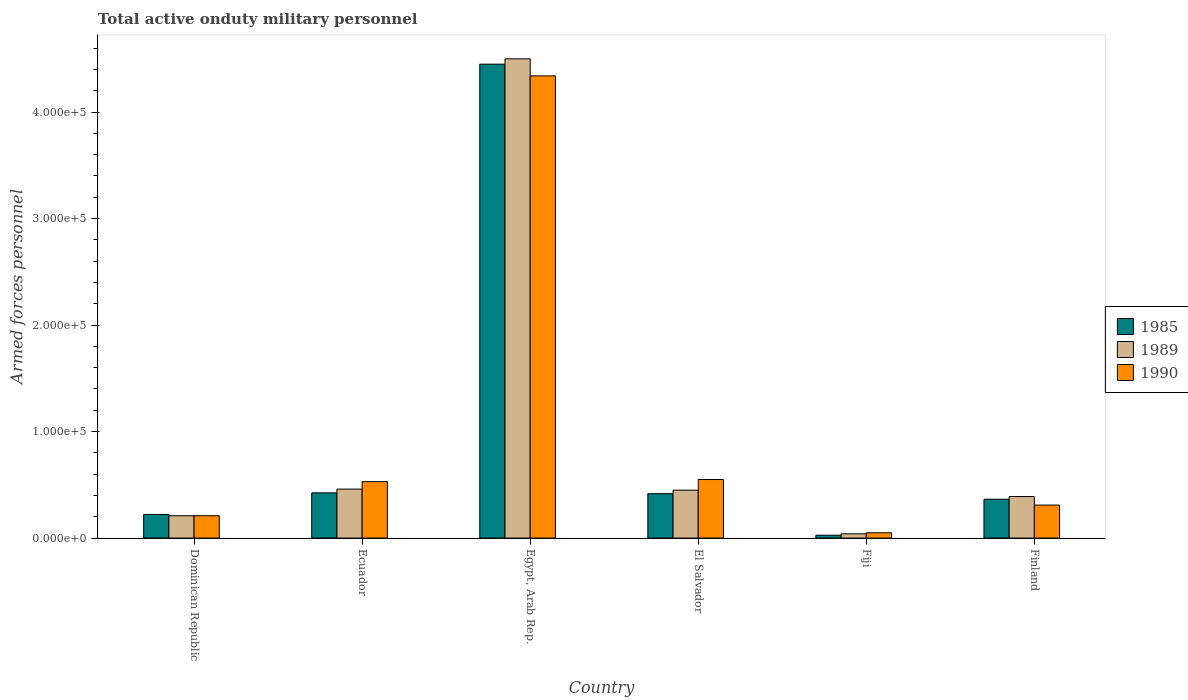How many different coloured bars are there?
Give a very brief answer. 3. How many groups of bars are there?
Ensure brevity in your answer.  6. What is the number of armed forces personnel in 1985 in Egypt, Arab Rep.?
Offer a very short reply. 4.45e+05. Across all countries, what is the minimum number of armed forces personnel in 1985?
Keep it short and to the point. 2700. In which country was the number of armed forces personnel in 1990 maximum?
Ensure brevity in your answer.  Egypt, Arab Rep. In which country was the number of armed forces personnel in 1985 minimum?
Give a very brief answer. Fiji. What is the total number of armed forces personnel in 1990 in the graph?
Give a very brief answer. 5.99e+05. What is the difference between the number of armed forces personnel in 1990 in Dominican Republic and that in Ecuador?
Make the answer very short. -3.20e+04. What is the difference between the number of armed forces personnel in 1985 in El Salvador and the number of armed forces personnel in 1990 in Ecuador?
Keep it short and to the point. -1.13e+04. What is the average number of armed forces personnel in 1989 per country?
Give a very brief answer. 1.01e+05. What is the difference between the number of armed forces personnel of/in 1989 and number of armed forces personnel of/in 1985 in Egypt, Arab Rep.?
Make the answer very short. 5000. In how many countries, is the number of armed forces personnel in 1989 greater than 420000?
Offer a very short reply. 1. What is the ratio of the number of armed forces personnel in 1985 in Ecuador to that in Finland?
Provide a short and direct response. 1.16. Is the difference between the number of armed forces personnel in 1989 in El Salvador and Fiji greater than the difference between the number of armed forces personnel in 1985 in El Salvador and Fiji?
Offer a very short reply. Yes. What is the difference between the highest and the second highest number of armed forces personnel in 1990?
Provide a succinct answer. 3.81e+05. What is the difference between the highest and the lowest number of armed forces personnel in 1985?
Make the answer very short. 4.42e+05. Does the graph contain grids?
Give a very brief answer. No. Where does the legend appear in the graph?
Give a very brief answer. Center right. What is the title of the graph?
Provide a short and direct response. Total active onduty military personnel. Does "1985" appear as one of the legend labels in the graph?
Offer a very short reply. Yes. What is the label or title of the X-axis?
Give a very brief answer. Country. What is the label or title of the Y-axis?
Keep it short and to the point. Armed forces personnel. What is the Armed forces personnel of 1985 in Dominican Republic?
Make the answer very short. 2.22e+04. What is the Armed forces personnel in 1989 in Dominican Republic?
Provide a short and direct response. 2.10e+04. What is the Armed forces personnel in 1990 in Dominican Republic?
Your response must be concise. 2.10e+04. What is the Armed forces personnel of 1985 in Ecuador?
Provide a succinct answer. 4.25e+04. What is the Armed forces personnel in 1989 in Ecuador?
Provide a short and direct response. 4.60e+04. What is the Armed forces personnel of 1990 in Ecuador?
Provide a short and direct response. 5.30e+04. What is the Armed forces personnel in 1985 in Egypt, Arab Rep.?
Provide a succinct answer. 4.45e+05. What is the Armed forces personnel in 1989 in Egypt, Arab Rep.?
Provide a succinct answer. 4.50e+05. What is the Armed forces personnel of 1990 in Egypt, Arab Rep.?
Your response must be concise. 4.34e+05. What is the Armed forces personnel of 1985 in El Salvador?
Offer a terse response. 4.17e+04. What is the Armed forces personnel of 1989 in El Salvador?
Your response must be concise. 4.50e+04. What is the Armed forces personnel in 1990 in El Salvador?
Offer a terse response. 5.50e+04. What is the Armed forces personnel in 1985 in Fiji?
Ensure brevity in your answer.  2700. What is the Armed forces personnel in 1989 in Fiji?
Make the answer very short. 4000. What is the Armed forces personnel of 1990 in Fiji?
Make the answer very short. 5000. What is the Armed forces personnel of 1985 in Finland?
Offer a very short reply. 3.65e+04. What is the Armed forces personnel of 1989 in Finland?
Offer a very short reply. 3.90e+04. What is the Armed forces personnel of 1990 in Finland?
Provide a short and direct response. 3.10e+04. Across all countries, what is the maximum Armed forces personnel of 1985?
Make the answer very short. 4.45e+05. Across all countries, what is the maximum Armed forces personnel of 1990?
Ensure brevity in your answer.  4.34e+05. Across all countries, what is the minimum Armed forces personnel in 1985?
Your answer should be compact. 2700. Across all countries, what is the minimum Armed forces personnel in 1989?
Give a very brief answer. 4000. What is the total Armed forces personnel in 1985 in the graph?
Ensure brevity in your answer.  5.91e+05. What is the total Armed forces personnel in 1989 in the graph?
Give a very brief answer. 6.05e+05. What is the total Armed forces personnel of 1990 in the graph?
Your answer should be compact. 5.99e+05. What is the difference between the Armed forces personnel of 1985 in Dominican Republic and that in Ecuador?
Your response must be concise. -2.03e+04. What is the difference between the Armed forces personnel in 1989 in Dominican Republic and that in Ecuador?
Keep it short and to the point. -2.50e+04. What is the difference between the Armed forces personnel in 1990 in Dominican Republic and that in Ecuador?
Keep it short and to the point. -3.20e+04. What is the difference between the Armed forces personnel in 1985 in Dominican Republic and that in Egypt, Arab Rep.?
Provide a short and direct response. -4.23e+05. What is the difference between the Armed forces personnel of 1989 in Dominican Republic and that in Egypt, Arab Rep.?
Keep it short and to the point. -4.29e+05. What is the difference between the Armed forces personnel in 1990 in Dominican Republic and that in Egypt, Arab Rep.?
Ensure brevity in your answer.  -4.13e+05. What is the difference between the Armed forces personnel of 1985 in Dominican Republic and that in El Salvador?
Provide a succinct answer. -1.95e+04. What is the difference between the Armed forces personnel of 1989 in Dominican Republic and that in El Salvador?
Offer a terse response. -2.40e+04. What is the difference between the Armed forces personnel in 1990 in Dominican Republic and that in El Salvador?
Offer a terse response. -3.40e+04. What is the difference between the Armed forces personnel in 1985 in Dominican Republic and that in Fiji?
Ensure brevity in your answer.  1.95e+04. What is the difference between the Armed forces personnel of 1989 in Dominican Republic and that in Fiji?
Your answer should be compact. 1.70e+04. What is the difference between the Armed forces personnel in 1990 in Dominican Republic and that in Fiji?
Offer a very short reply. 1.60e+04. What is the difference between the Armed forces personnel of 1985 in Dominican Republic and that in Finland?
Offer a terse response. -1.43e+04. What is the difference between the Armed forces personnel of 1989 in Dominican Republic and that in Finland?
Give a very brief answer. -1.80e+04. What is the difference between the Armed forces personnel of 1985 in Ecuador and that in Egypt, Arab Rep.?
Provide a short and direct response. -4.02e+05. What is the difference between the Armed forces personnel of 1989 in Ecuador and that in Egypt, Arab Rep.?
Provide a succinct answer. -4.04e+05. What is the difference between the Armed forces personnel in 1990 in Ecuador and that in Egypt, Arab Rep.?
Make the answer very short. -3.81e+05. What is the difference between the Armed forces personnel of 1985 in Ecuador and that in El Salvador?
Offer a very short reply. 800. What is the difference between the Armed forces personnel in 1989 in Ecuador and that in El Salvador?
Make the answer very short. 1000. What is the difference between the Armed forces personnel of 1990 in Ecuador and that in El Salvador?
Give a very brief answer. -2000. What is the difference between the Armed forces personnel of 1985 in Ecuador and that in Fiji?
Provide a short and direct response. 3.98e+04. What is the difference between the Armed forces personnel in 1989 in Ecuador and that in Fiji?
Your response must be concise. 4.20e+04. What is the difference between the Armed forces personnel in 1990 in Ecuador and that in Fiji?
Your response must be concise. 4.80e+04. What is the difference between the Armed forces personnel in 1985 in Ecuador and that in Finland?
Offer a very short reply. 6000. What is the difference between the Armed forces personnel in 1989 in Ecuador and that in Finland?
Your response must be concise. 7000. What is the difference between the Armed forces personnel in 1990 in Ecuador and that in Finland?
Offer a very short reply. 2.20e+04. What is the difference between the Armed forces personnel of 1985 in Egypt, Arab Rep. and that in El Salvador?
Your answer should be very brief. 4.03e+05. What is the difference between the Armed forces personnel in 1989 in Egypt, Arab Rep. and that in El Salvador?
Your answer should be compact. 4.05e+05. What is the difference between the Armed forces personnel of 1990 in Egypt, Arab Rep. and that in El Salvador?
Keep it short and to the point. 3.79e+05. What is the difference between the Armed forces personnel of 1985 in Egypt, Arab Rep. and that in Fiji?
Provide a short and direct response. 4.42e+05. What is the difference between the Armed forces personnel of 1989 in Egypt, Arab Rep. and that in Fiji?
Make the answer very short. 4.46e+05. What is the difference between the Armed forces personnel of 1990 in Egypt, Arab Rep. and that in Fiji?
Offer a very short reply. 4.29e+05. What is the difference between the Armed forces personnel of 1985 in Egypt, Arab Rep. and that in Finland?
Your response must be concise. 4.08e+05. What is the difference between the Armed forces personnel of 1989 in Egypt, Arab Rep. and that in Finland?
Offer a terse response. 4.11e+05. What is the difference between the Armed forces personnel in 1990 in Egypt, Arab Rep. and that in Finland?
Make the answer very short. 4.03e+05. What is the difference between the Armed forces personnel of 1985 in El Salvador and that in Fiji?
Your answer should be very brief. 3.90e+04. What is the difference between the Armed forces personnel in 1989 in El Salvador and that in Fiji?
Offer a very short reply. 4.10e+04. What is the difference between the Armed forces personnel in 1990 in El Salvador and that in Fiji?
Offer a very short reply. 5.00e+04. What is the difference between the Armed forces personnel in 1985 in El Salvador and that in Finland?
Make the answer very short. 5200. What is the difference between the Armed forces personnel of 1989 in El Salvador and that in Finland?
Offer a terse response. 6000. What is the difference between the Armed forces personnel in 1990 in El Salvador and that in Finland?
Offer a terse response. 2.40e+04. What is the difference between the Armed forces personnel in 1985 in Fiji and that in Finland?
Provide a succinct answer. -3.38e+04. What is the difference between the Armed forces personnel in 1989 in Fiji and that in Finland?
Offer a terse response. -3.50e+04. What is the difference between the Armed forces personnel of 1990 in Fiji and that in Finland?
Offer a terse response. -2.60e+04. What is the difference between the Armed forces personnel of 1985 in Dominican Republic and the Armed forces personnel of 1989 in Ecuador?
Give a very brief answer. -2.38e+04. What is the difference between the Armed forces personnel in 1985 in Dominican Republic and the Armed forces personnel in 1990 in Ecuador?
Offer a very short reply. -3.08e+04. What is the difference between the Armed forces personnel of 1989 in Dominican Republic and the Armed forces personnel of 1990 in Ecuador?
Your answer should be very brief. -3.20e+04. What is the difference between the Armed forces personnel of 1985 in Dominican Republic and the Armed forces personnel of 1989 in Egypt, Arab Rep.?
Your answer should be compact. -4.28e+05. What is the difference between the Armed forces personnel in 1985 in Dominican Republic and the Armed forces personnel in 1990 in Egypt, Arab Rep.?
Keep it short and to the point. -4.12e+05. What is the difference between the Armed forces personnel in 1989 in Dominican Republic and the Armed forces personnel in 1990 in Egypt, Arab Rep.?
Your answer should be very brief. -4.13e+05. What is the difference between the Armed forces personnel of 1985 in Dominican Republic and the Armed forces personnel of 1989 in El Salvador?
Your response must be concise. -2.28e+04. What is the difference between the Armed forces personnel of 1985 in Dominican Republic and the Armed forces personnel of 1990 in El Salvador?
Your answer should be very brief. -3.28e+04. What is the difference between the Armed forces personnel of 1989 in Dominican Republic and the Armed forces personnel of 1990 in El Salvador?
Ensure brevity in your answer.  -3.40e+04. What is the difference between the Armed forces personnel of 1985 in Dominican Republic and the Armed forces personnel of 1989 in Fiji?
Offer a very short reply. 1.82e+04. What is the difference between the Armed forces personnel of 1985 in Dominican Republic and the Armed forces personnel of 1990 in Fiji?
Provide a succinct answer. 1.72e+04. What is the difference between the Armed forces personnel in 1989 in Dominican Republic and the Armed forces personnel in 1990 in Fiji?
Your answer should be compact. 1.60e+04. What is the difference between the Armed forces personnel in 1985 in Dominican Republic and the Armed forces personnel in 1989 in Finland?
Provide a succinct answer. -1.68e+04. What is the difference between the Armed forces personnel in 1985 in Dominican Republic and the Armed forces personnel in 1990 in Finland?
Keep it short and to the point. -8800. What is the difference between the Armed forces personnel of 1985 in Ecuador and the Armed forces personnel of 1989 in Egypt, Arab Rep.?
Your response must be concise. -4.08e+05. What is the difference between the Armed forces personnel of 1985 in Ecuador and the Armed forces personnel of 1990 in Egypt, Arab Rep.?
Your answer should be very brief. -3.92e+05. What is the difference between the Armed forces personnel of 1989 in Ecuador and the Armed forces personnel of 1990 in Egypt, Arab Rep.?
Provide a short and direct response. -3.88e+05. What is the difference between the Armed forces personnel in 1985 in Ecuador and the Armed forces personnel in 1989 in El Salvador?
Your response must be concise. -2500. What is the difference between the Armed forces personnel of 1985 in Ecuador and the Armed forces personnel of 1990 in El Salvador?
Offer a very short reply. -1.25e+04. What is the difference between the Armed forces personnel in 1989 in Ecuador and the Armed forces personnel in 1990 in El Salvador?
Provide a short and direct response. -9000. What is the difference between the Armed forces personnel of 1985 in Ecuador and the Armed forces personnel of 1989 in Fiji?
Make the answer very short. 3.85e+04. What is the difference between the Armed forces personnel in 1985 in Ecuador and the Armed forces personnel in 1990 in Fiji?
Provide a succinct answer. 3.75e+04. What is the difference between the Armed forces personnel of 1989 in Ecuador and the Armed forces personnel of 1990 in Fiji?
Make the answer very short. 4.10e+04. What is the difference between the Armed forces personnel in 1985 in Ecuador and the Armed forces personnel in 1989 in Finland?
Offer a very short reply. 3500. What is the difference between the Armed forces personnel of 1985 in Ecuador and the Armed forces personnel of 1990 in Finland?
Your response must be concise. 1.15e+04. What is the difference between the Armed forces personnel in 1989 in Ecuador and the Armed forces personnel in 1990 in Finland?
Offer a terse response. 1.50e+04. What is the difference between the Armed forces personnel of 1985 in Egypt, Arab Rep. and the Armed forces personnel of 1989 in El Salvador?
Give a very brief answer. 4.00e+05. What is the difference between the Armed forces personnel of 1985 in Egypt, Arab Rep. and the Armed forces personnel of 1990 in El Salvador?
Offer a terse response. 3.90e+05. What is the difference between the Armed forces personnel in 1989 in Egypt, Arab Rep. and the Armed forces personnel in 1990 in El Salvador?
Your answer should be compact. 3.95e+05. What is the difference between the Armed forces personnel in 1985 in Egypt, Arab Rep. and the Armed forces personnel in 1989 in Fiji?
Ensure brevity in your answer.  4.41e+05. What is the difference between the Armed forces personnel in 1989 in Egypt, Arab Rep. and the Armed forces personnel in 1990 in Fiji?
Your answer should be compact. 4.45e+05. What is the difference between the Armed forces personnel of 1985 in Egypt, Arab Rep. and the Armed forces personnel of 1989 in Finland?
Provide a short and direct response. 4.06e+05. What is the difference between the Armed forces personnel of 1985 in Egypt, Arab Rep. and the Armed forces personnel of 1990 in Finland?
Provide a short and direct response. 4.14e+05. What is the difference between the Armed forces personnel of 1989 in Egypt, Arab Rep. and the Armed forces personnel of 1990 in Finland?
Provide a succinct answer. 4.19e+05. What is the difference between the Armed forces personnel in 1985 in El Salvador and the Armed forces personnel in 1989 in Fiji?
Your answer should be very brief. 3.77e+04. What is the difference between the Armed forces personnel in 1985 in El Salvador and the Armed forces personnel in 1990 in Fiji?
Give a very brief answer. 3.67e+04. What is the difference between the Armed forces personnel of 1985 in El Salvador and the Armed forces personnel of 1989 in Finland?
Give a very brief answer. 2700. What is the difference between the Armed forces personnel in 1985 in El Salvador and the Armed forces personnel in 1990 in Finland?
Give a very brief answer. 1.07e+04. What is the difference between the Armed forces personnel in 1989 in El Salvador and the Armed forces personnel in 1990 in Finland?
Ensure brevity in your answer.  1.40e+04. What is the difference between the Armed forces personnel in 1985 in Fiji and the Armed forces personnel in 1989 in Finland?
Keep it short and to the point. -3.63e+04. What is the difference between the Armed forces personnel of 1985 in Fiji and the Armed forces personnel of 1990 in Finland?
Offer a terse response. -2.83e+04. What is the difference between the Armed forces personnel in 1989 in Fiji and the Armed forces personnel in 1990 in Finland?
Offer a very short reply. -2.70e+04. What is the average Armed forces personnel in 1985 per country?
Make the answer very short. 9.84e+04. What is the average Armed forces personnel in 1989 per country?
Ensure brevity in your answer.  1.01e+05. What is the average Armed forces personnel in 1990 per country?
Offer a very short reply. 9.98e+04. What is the difference between the Armed forces personnel of 1985 and Armed forces personnel of 1989 in Dominican Republic?
Offer a terse response. 1200. What is the difference between the Armed forces personnel of 1985 and Armed forces personnel of 1990 in Dominican Republic?
Ensure brevity in your answer.  1200. What is the difference between the Armed forces personnel of 1989 and Armed forces personnel of 1990 in Dominican Republic?
Provide a short and direct response. 0. What is the difference between the Armed forces personnel of 1985 and Armed forces personnel of 1989 in Ecuador?
Your response must be concise. -3500. What is the difference between the Armed forces personnel of 1985 and Armed forces personnel of 1990 in Ecuador?
Make the answer very short. -1.05e+04. What is the difference between the Armed forces personnel in 1989 and Armed forces personnel in 1990 in Ecuador?
Your answer should be very brief. -7000. What is the difference between the Armed forces personnel in 1985 and Armed forces personnel in 1989 in Egypt, Arab Rep.?
Provide a succinct answer. -5000. What is the difference between the Armed forces personnel of 1985 and Armed forces personnel of 1990 in Egypt, Arab Rep.?
Keep it short and to the point. 1.10e+04. What is the difference between the Armed forces personnel of 1989 and Armed forces personnel of 1990 in Egypt, Arab Rep.?
Make the answer very short. 1.60e+04. What is the difference between the Armed forces personnel in 1985 and Armed forces personnel in 1989 in El Salvador?
Keep it short and to the point. -3300. What is the difference between the Armed forces personnel of 1985 and Armed forces personnel of 1990 in El Salvador?
Provide a succinct answer. -1.33e+04. What is the difference between the Armed forces personnel in 1985 and Armed forces personnel in 1989 in Fiji?
Your answer should be compact. -1300. What is the difference between the Armed forces personnel in 1985 and Armed forces personnel in 1990 in Fiji?
Your answer should be very brief. -2300. What is the difference between the Armed forces personnel of 1989 and Armed forces personnel of 1990 in Fiji?
Give a very brief answer. -1000. What is the difference between the Armed forces personnel in 1985 and Armed forces personnel in 1989 in Finland?
Your answer should be compact. -2500. What is the difference between the Armed forces personnel in 1985 and Armed forces personnel in 1990 in Finland?
Keep it short and to the point. 5500. What is the difference between the Armed forces personnel of 1989 and Armed forces personnel of 1990 in Finland?
Give a very brief answer. 8000. What is the ratio of the Armed forces personnel in 1985 in Dominican Republic to that in Ecuador?
Make the answer very short. 0.52. What is the ratio of the Armed forces personnel in 1989 in Dominican Republic to that in Ecuador?
Ensure brevity in your answer.  0.46. What is the ratio of the Armed forces personnel in 1990 in Dominican Republic to that in Ecuador?
Your answer should be compact. 0.4. What is the ratio of the Armed forces personnel in 1985 in Dominican Republic to that in Egypt, Arab Rep.?
Make the answer very short. 0.05. What is the ratio of the Armed forces personnel in 1989 in Dominican Republic to that in Egypt, Arab Rep.?
Keep it short and to the point. 0.05. What is the ratio of the Armed forces personnel of 1990 in Dominican Republic to that in Egypt, Arab Rep.?
Offer a terse response. 0.05. What is the ratio of the Armed forces personnel in 1985 in Dominican Republic to that in El Salvador?
Keep it short and to the point. 0.53. What is the ratio of the Armed forces personnel of 1989 in Dominican Republic to that in El Salvador?
Provide a succinct answer. 0.47. What is the ratio of the Armed forces personnel of 1990 in Dominican Republic to that in El Salvador?
Offer a very short reply. 0.38. What is the ratio of the Armed forces personnel in 1985 in Dominican Republic to that in Fiji?
Ensure brevity in your answer.  8.22. What is the ratio of the Armed forces personnel of 1989 in Dominican Republic to that in Fiji?
Offer a very short reply. 5.25. What is the ratio of the Armed forces personnel of 1985 in Dominican Republic to that in Finland?
Provide a succinct answer. 0.61. What is the ratio of the Armed forces personnel of 1989 in Dominican Republic to that in Finland?
Provide a succinct answer. 0.54. What is the ratio of the Armed forces personnel in 1990 in Dominican Republic to that in Finland?
Offer a very short reply. 0.68. What is the ratio of the Armed forces personnel in 1985 in Ecuador to that in Egypt, Arab Rep.?
Keep it short and to the point. 0.1. What is the ratio of the Armed forces personnel of 1989 in Ecuador to that in Egypt, Arab Rep.?
Provide a succinct answer. 0.1. What is the ratio of the Armed forces personnel of 1990 in Ecuador to that in Egypt, Arab Rep.?
Ensure brevity in your answer.  0.12. What is the ratio of the Armed forces personnel in 1985 in Ecuador to that in El Salvador?
Provide a succinct answer. 1.02. What is the ratio of the Armed forces personnel in 1989 in Ecuador to that in El Salvador?
Keep it short and to the point. 1.02. What is the ratio of the Armed forces personnel in 1990 in Ecuador to that in El Salvador?
Ensure brevity in your answer.  0.96. What is the ratio of the Armed forces personnel of 1985 in Ecuador to that in Fiji?
Offer a terse response. 15.74. What is the ratio of the Armed forces personnel in 1989 in Ecuador to that in Fiji?
Provide a short and direct response. 11.5. What is the ratio of the Armed forces personnel in 1990 in Ecuador to that in Fiji?
Your answer should be compact. 10.6. What is the ratio of the Armed forces personnel in 1985 in Ecuador to that in Finland?
Keep it short and to the point. 1.16. What is the ratio of the Armed forces personnel of 1989 in Ecuador to that in Finland?
Provide a succinct answer. 1.18. What is the ratio of the Armed forces personnel in 1990 in Ecuador to that in Finland?
Offer a terse response. 1.71. What is the ratio of the Armed forces personnel of 1985 in Egypt, Arab Rep. to that in El Salvador?
Your response must be concise. 10.67. What is the ratio of the Armed forces personnel of 1990 in Egypt, Arab Rep. to that in El Salvador?
Provide a succinct answer. 7.89. What is the ratio of the Armed forces personnel of 1985 in Egypt, Arab Rep. to that in Fiji?
Ensure brevity in your answer.  164.81. What is the ratio of the Armed forces personnel in 1989 in Egypt, Arab Rep. to that in Fiji?
Provide a short and direct response. 112.5. What is the ratio of the Armed forces personnel in 1990 in Egypt, Arab Rep. to that in Fiji?
Give a very brief answer. 86.8. What is the ratio of the Armed forces personnel in 1985 in Egypt, Arab Rep. to that in Finland?
Offer a very short reply. 12.19. What is the ratio of the Armed forces personnel of 1989 in Egypt, Arab Rep. to that in Finland?
Give a very brief answer. 11.54. What is the ratio of the Armed forces personnel in 1990 in Egypt, Arab Rep. to that in Finland?
Offer a terse response. 14. What is the ratio of the Armed forces personnel of 1985 in El Salvador to that in Fiji?
Make the answer very short. 15.44. What is the ratio of the Armed forces personnel of 1989 in El Salvador to that in Fiji?
Ensure brevity in your answer.  11.25. What is the ratio of the Armed forces personnel in 1990 in El Salvador to that in Fiji?
Your answer should be very brief. 11. What is the ratio of the Armed forces personnel of 1985 in El Salvador to that in Finland?
Ensure brevity in your answer.  1.14. What is the ratio of the Armed forces personnel of 1989 in El Salvador to that in Finland?
Make the answer very short. 1.15. What is the ratio of the Armed forces personnel of 1990 in El Salvador to that in Finland?
Your answer should be compact. 1.77. What is the ratio of the Armed forces personnel in 1985 in Fiji to that in Finland?
Your answer should be very brief. 0.07. What is the ratio of the Armed forces personnel in 1989 in Fiji to that in Finland?
Make the answer very short. 0.1. What is the ratio of the Armed forces personnel of 1990 in Fiji to that in Finland?
Keep it short and to the point. 0.16. What is the difference between the highest and the second highest Armed forces personnel in 1985?
Your answer should be compact. 4.02e+05. What is the difference between the highest and the second highest Armed forces personnel of 1989?
Keep it short and to the point. 4.04e+05. What is the difference between the highest and the second highest Armed forces personnel in 1990?
Provide a short and direct response. 3.79e+05. What is the difference between the highest and the lowest Armed forces personnel in 1985?
Provide a succinct answer. 4.42e+05. What is the difference between the highest and the lowest Armed forces personnel of 1989?
Keep it short and to the point. 4.46e+05. What is the difference between the highest and the lowest Armed forces personnel in 1990?
Provide a short and direct response. 4.29e+05. 